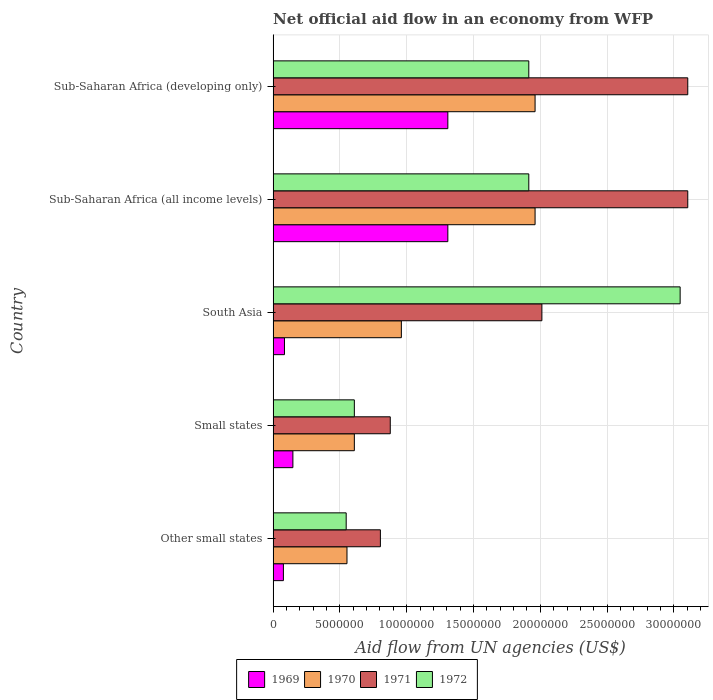How many different coloured bars are there?
Ensure brevity in your answer.  4. How many bars are there on the 5th tick from the top?
Offer a terse response. 4. What is the label of the 4th group of bars from the top?
Offer a very short reply. Small states. In how many cases, is the number of bars for a given country not equal to the number of legend labels?
Make the answer very short. 0. What is the net official aid flow in 1969 in South Asia?
Keep it short and to the point. 8.50e+05. Across all countries, what is the maximum net official aid flow in 1971?
Make the answer very short. 3.10e+07. Across all countries, what is the minimum net official aid flow in 1972?
Provide a short and direct response. 5.47e+06. In which country was the net official aid flow in 1972 minimum?
Your answer should be very brief. Other small states. What is the total net official aid flow in 1969 in the graph?
Keep it short and to the point. 2.93e+07. What is the difference between the net official aid flow in 1972 in Other small states and that in South Asia?
Provide a succinct answer. -2.50e+07. What is the difference between the net official aid flow in 1969 in Sub-Saharan Africa (all income levels) and the net official aid flow in 1972 in South Asia?
Your answer should be very brief. -1.74e+07. What is the average net official aid flow in 1970 per country?
Keep it short and to the point. 1.21e+07. What is the difference between the net official aid flow in 1969 and net official aid flow in 1972 in South Asia?
Provide a short and direct response. -2.96e+07. What is the ratio of the net official aid flow in 1971 in Other small states to that in South Asia?
Provide a short and direct response. 0.4. Is the difference between the net official aid flow in 1969 in Small states and Sub-Saharan Africa (developing only) greater than the difference between the net official aid flow in 1972 in Small states and Sub-Saharan Africa (developing only)?
Provide a succinct answer. Yes. What is the difference between the highest and the lowest net official aid flow in 1971?
Ensure brevity in your answer.  2.30e+07. In how many countries, is the net official aid flow in 1969 greater than the average net official aid flow in 1969 taken over all countries?
Provide a short and direct response. 2. What does the 3rd bar from the bottom in Small states represents?
Provide a succinct answer. 1971. Is it the case that in every country, the sum of the net official aid flow in 1969 and net official aid flow in 1971 is greater than the net official aid flow in 1970?
Your response must be concise. Yes. How many countries are there in the graph?
Your answer should be compact. 5. How are the legend labels stacked?
Offer a terse response. Horizontal. What is the title of the graph?
Ensure brevity in your answer.  Net official aid flow in an economy from WFP. What is the label or title of the X-axis?
Provide a succinct answer. Aid flow from UN agencies (US$). What is the Aid flow from UN agencies (US$) in 1969 in Other small states?
Give a very brief answer. 7.70e+05. What is the Aid flow from UN agencies (US$) in 1970 in Other small states?
Keep it short and to the point. 5.53e+06. What is the Aid flow from UN agencies (US$) in 1971 in Other small states?
Give a very brief answer. 8.03e+06. What is the Aid flow from UN agencies (US$) in 1972 in Other small states?
Provide a succinct answer. 5.47e+06. What is the Aid flow from UN agencies (US$) of 1969 in Small states?
Your answer should be very brief. 1.48e+06. What is the Aid flow from UN agencies (US$) in 1970 in Small states?
Give a very brief answer. 6.08e+06. What is the Aid flow from UN agencies (US$) of 1971 in Small states?
Offer a terse response. 8.77e+06. What is the Aid flow from UN agencies (US$) in 1972 in Small states?
Offer a very short reply. 6.08e+06. What is the Aid flow from UN agencies (US$) of 1969 in South Asia?
Your answer should be compact. 8.50e+05. What is the Aid flow from UN agencies (US$) in 1970 in South Asia?
Your answer should be very brief. 9.60e+06. What is the Aid flow from UN agencies (US$) in 1971 in South Asia?
Offer a very short reply. 2.01e+07. What is the Aid flow from UN agencies (US$) of 1972 in South Asia?
Offer a terse response. 3.05e+07. What is the Aid flow from UN agencies (US$) of 1969 in Sub-Saharan Africa (all income levels)?
Keep it short and to the point. 1.31e+07. What is the Aid flow from UN agencies (US$) in 1970 in Sub-Saharan Africa (all income levels)?
Give a very brief answer. 1.96e+07. What is the Aid flow from UN agencies (US$) of 1971 in Sub-Saharan Africa (all income levels)?
Provide a succinct answer. 3.10e+07. What is the Aid flow from UN agencies (US$) of 1972 in Sub-Saharan Africa (all income levels)?
Offer a terse response. 1.91e+07. What is the Aid flow from UN agencies (US$) in 1969 in Sub-Saharan Africa (developing only)?
Your answer should be very brief. 1.31e+07. What is the Aid flow from UN agencies (US$) of 1970 in Sub-Saharan Africa (developing only)?
Ensure brevity in your answer.  1.96e+07. What is the Aid flow from UN agencies (US$) in 1971 in Sub-Saharan Africa (developing only)?
Keep it short and to the point. 3.10e+07. What is the Aid flow from UN agencies (US$) in 1972 in Sub-Saharan Africa (developing only)?
Offer a very short reply. 1.91e+07. Across all countries, what is the maximum Aid flow from UN agencies (US$) in 1969?
Provide a succinct answer. 1.31e+07. Across all countries, what is the maximum Aid flow from UN agencies (US$) of 1970?
Your response must be concise. 1.96e+07. Across all countries, what is the maximum Aid flow from UN agencies (US$) of 1971?
Keep it short and to the point. 3.10e+07. Across all countries, what is the maximum Aid flow from UN agencies (US$) of 1972?
Ensure brevity in your answer.  3.05e+07. Across all countries, what is the minimum Aid flow from UN agencies (US$) of 1969?
Make the answer very short. 7.70e+05. Across all countries, what is the minimum Aid flow from UN agencies (US$) in 1970?
Your answer should be compact. 5.53e+06. Across all countries, what is the minimum Aid flow from UN agencies (US$) in 1971?
Provide a short and direct response. 8.03e+06. Across all countries, what is the minimum Aid flow from UN agencies (US$) in 1972?
Offer a very short reply. 5.47e+06. What is the total Aid flow from UN agencies (US$) of 1969 in the graph?
Give a very brief answer. 2.93e+07. What is the total Aid flow from UN agencies (US$) of 1970 in the graph?
Keep it short and to the point. 6.04e+07. What is the total Aid flow from UN agencies (US$) of 1971 in the graph?
Offer a terse response. 9.90e+07. What is the total Aid flow from UN agencies (US$) of 1972 in the graph?
Your response must be concise. 8.03e+07. What is the difference between the Aid flow from UN agencies (US$) of 1969 in Other small states and that in Small states?
Your answer should be compact. -7.10e+05. What is the difference between the Aid flow from UN agencies (US$) in 1970 in Other small states and that in Small states?
Give a very brief answer. -5.50e+05. What is the difference between the Aid flow from UN agencies (US$) of 1971 in Other small states and that in Small states?
Ensure brevity in your answer.  -7.40e+05. What is the difference between the Aid flow from UN agencies (US$) of 1972 in Other small states and that in Small states?
Your answer should be compact. -6.10e+05. What is the difference between the Aid flow from UN agencies (US$) of 1969 in Other small states and that in South Asia?
Make the answer very short. -8.00e+04. What is the difference between the Aid flow from UN agencies (US$) in 1970 in Other small states and that in South Asia?
Your answer should be very brief. -4.07e+06. What is the difference between the Aid flow from UN agencies (US$) of 1971 in Other small states and that in South Asia?
Provide a short and direct response. -1.21e+07. What is the difference between the Aid flow from UN agencies (US$) of 1972 in Other small states and that in South Asia?
Give a very brief answer. -2.50e+07. What is the difference between the Aid flow from UN agencies (US$) of 1969 in Other small states and that in Sub-Saharan Africa (all income levels)?
Ensure brevity in your answer.  -1.23e+07. What is the difference between the Aid flow from UN agencies (US$) of 1970 in Other small states and that in Sub-Saharan Africa (all income levels)?
Offer a terse response. -1.41e+07. What is the difference between the Aid flow from UN agencies (US$) in 1971 in Other small states and that in Sub-Saharan Africa (all income levels)?
Ensure brevity in your answer.  -2.30e+07. What is the difference between the Aid flow from UN agencies (US$) of 1972 in Other small states and that in Sub-Saharan Africa (all income levels)?
Provide a succinct answer. -1.37e+07. What is the difference between the Aid flow from UN agencies (US$) of 1969 in Other small states and that in Sub-Saharan Africa (developing only)?
Keep it short and to the point. -1.23e+07. What is the difference between the Aid flow from UN agencies (US$) in 1970 in Other small states and that in Sub-Saharan Africa (developing only)?
Provide a short and direct response. -1.41e+07. What is the difference between the Aid flow from UN agencies (US$) in 1971 in Other small states and that in Sub-Saharan Africa (developing only)?
Your answer should be compact. -2.30e+07. What is the difference between the Aid flow from UN agencies (US$) in 1972 in Other small states and that in Sub-Saharan Africa (developing only)?
Keep it short and to the point. -1.37e+07. What is the difference between the Aid flow from UN agencies (US$) of 1969 in Small states and that in South Asia?
Your answer should be compact. 6.30e+05. What is the difference between the Aid flow from UN agencies (US$) in 1970 in Small states and that in South Asia?
Your response must be concise. -3.52e+06. What is the difference between the Aid flow from UN agencies (US$) of 1971 in Small states and that in South Asia?
Give a very brief answer. -1.14e+07. What is the difference between the Aid flow from UN agencies (US$) in 1972 in Small states and that in South Asia?
Provide a succinct answer. -2.44e+07. What is the difference between the Aid flow from UN agencies (US$) in 1969 in Small states and that in Sub-Saharan Africa (all income levels)?
Offer a very short reply. -1.16e+07. What is the difference between the Aid flow from UN agencies (US$) in 1970 in Small states and that in Sub-Saharan Africa (all income levels)?
Your response must be concise. -1.35e+07. What is the difference between the Aid flow from UN agencies (US$) in 1971 in Small states and that in Sub-Saharan Africa (all income levels)?
Your response must be concise. -2.23e+07. What is the difference between the Aid flow from UN agencies (US$) of 1972 in Small states and that in Sub-Saharan Africa (all income levels)?
Keep it short and to the point. -1.31e+07. What is the difference between the Aid flow from UN agencies (US$) of 1969 in Small states and that in Sub-Saharan Africa (developing only)?
Offer a terse response. -1.16e+07. What is the difference between the Aid flow from UN agencies (US$) in 1970 in Small states and that in Sub-Saharan Africa (developing only)?
Provide a short and direct response. -1.35e+07. What is the difference between the Aid flow from UN agencies (US$) of 1971 in Small states and that in Sub-Saharan Africa (developing only)?
Provide a short and direct response. -2.23e+07. What is the difference between the Aid flow from UN agencies (US$) in 1972 in Small states and that in Sub-Saharan Africa (developing only)?
Offer a terse response. -1.31e+07. What is the difference between the Aid flow from UN agencies (US$) of 1969 in South Asia and that in Sub-Saharan Africa (all income levels)?
Give a very brief answer. -1.22e+07. What is the difference between the Aid flow from UN agencies (US$) of 1970 in South Asia and that in Sub-Saharan Africa (all income levels)?
Give a very brief answer. -1.00e+07. What is the difference between the Aid flow from UN agencies (US$) in 1971 in South Asia and that in Sub-Saharan Africa (all income levels)?
Offer a terse response. -1.09e+07. What is the difference between the Aid flow from UN agencies (US$) in 1972 in South Asia and that in Sub-Saharan Africa (all income levels)?
Keep it short and to the point. 1.13e+07. What is the difference between the Aid flow from UN agencies (US$) in 1969 in South Asia and that in Sub-Saharan Africa (developing only)?
Provide a succinct answer. -1.22e+07. What is the difference between the Aid flow from UN agencies (US$) in 1970 in South Asia and that in Sub-Saharan Africa (developing only)?
Give a very brief answer. -1.00e+07. What is the difference between the Aid flow from UN agencies (US$) in 1971 in South Asia and that in Sub-Saharan Africa (developing only)?
Your answer should be very brief. -1.09e+07. What is the difference between the Aid flow from UN agencies (US$) of 1972 in South Asia and that in Sub-Saharan Africa (developing only)?
Your answer should be compact. 1.13e+07. What is the difference between the Aid flow from UN agencies (US$) of 1972 in Sub-Saharan Africa (all income levels) and that in Sub-Saharan Africa (developing only)?
Give a very brief answer. 0. What is the difference between the Aid flow from UN agencies (US$) of 1969 in Other small states and the Aid flow from UN agencies (US$) of 1970 in Small states?
Your response must be concise. -5.31e+06. What is the difference between the Aid flow from UN agencies (US$) in 1969 in Other small states and the Aid flow from UN agencies (US$) in 1971 in Small states?
Your response must be concise. -8.00e+06. What is the difference between the Aid flow from UN agencies (US$) in 1969 in Other small states and the Aid flow from UN agencies (US$) in 1972 in Small states?
Give a very brief answer. -5.31e+06. What is the difference between the Aid flow from UN agencies (US$) of 1970 in Other small states and the Aid flow from UN agencies (US$) of 1971 in Small states?
Provide a succinct answer. -3.24e+06. What is the difference between the Aid flow from UN agencies (US$) of 1970 in Other small states and the Aid flow from UN agencies (US$) of 1972 in Small states?
Give a very brief answer. -5.50e+05. What is the difference between the Aid flow from UN agencies (US$) of 1971 in Other small states and the Aid flow from UN agencies (US$) of 1972 in Small states?
Offer a terse response. 1.95e+06. What is the difference between the Aid flow from UN agencies (US$) in 1969 in Other small states and the Aid flow from UN agencies (US$) in 1970 in South Asia?
Your response must be concise. -8.83e+06. What is the difference between the Aid flow from UN agencies (US$) in 1969 in Other small states and the Aid flow from UN agencies (US$) in 1971 in South Asia?
Ensure brevity in your answer.  -1.94e+07. What is the difference between the Aid flow from UN agencies (US$) in 1969 in Other small states and the Aid flow from UN agencies (US$) in 1972 in South Asia?
Your answer should be compact. -2.97e+07. What is the difference between the Aid flow from UN agencies (US$) of 1970 in Other small states and the Aid flow from UN agencies (US$) of 1971 in South Asia?
Provide a succinct answer. -1.46e+07. What is the difference between the Aid flow from UN agencies (US$) of 1970 in Other small states and the Aid flow from UN agencies (US$) of 1972 in South Asia?
Keep it short and to the point. -2.49e+07. What is the difference between the Aid flow from UN agencies (US$) of 1971 in Other small states and the Aid flow from UN agencies (US$) of 1972 in South Asia?
Provide a short and direct response. -2.24e+07. What is the difference between the Aid flow from UN agencies (US$) in 1969 in Other small states and the Aid flow from UN agencies (US$) in 1970 in Sub-Saharan Africa (all income levels)?
Your answer should be very brief. -1.88e+07. What is the difference between the Aid flow from UN agencies (US$) of 1969 in Other small states and the Aid flow from UN agencies (US$) of 1971 in Sub-Saharan Africa (all income levels)?
Ensure brevity in your answer.  -3.03e+07. What is the difference between the Aid flow from UN agencies (US$) of 1969 in Other small states and the Aid flow from UN agencies (US$) of 1972 in Sub-Saharan Africa (all income levels)?
Your answer should be very brief. -1.84e+07. What is the difference between the Aid flow from UN agencies (US$) of 1970 in Other small states and the Aid flow from UN agencies (US$) of 1971 in Sub-Saharan Africa (all income levels)?
Provide a short and direct response. -2.55e+07. What is the difference between the Aid flow from UN agencies (US$) in 1970 in Other small states and the Aid flow from UN agencies (US$) in 1972 in Sub-Saharan Africa (all income levels)?
Make the answer very short. -1.36e+07. What is the difference between the Aid flow from UN agencies (US$) of 1971 in Other small states and the Aid flow from UN agencies (US$) of 1972 in Sub-Saharan Africa (all income levels)?
Make the answer very short. -1.11e+07. What is the difference between the Aid flow from UN agencies (US$) in 1969 in Other small states and the Aid flow from UN agencies (US$) in 1970 in Sub-Saharan Africa (developing only)?
Keep it short and to the point. -1.88e+07. What is the difference between the Aid flow from UN agencies (US$) in 1969 in Other small states and the Aid flow from UN agencies (US$) in 1971 in Sub-Saharan Africa (developing only)?
Ensure brevity in your answer.  -3.03e+07. What is the difference between the Aid flow from UN agencies (US$) of 1969 in Other small states and the Aid flow from UN agencies (US$) of 1972 in Sub-Saharan Africa (developing only)?
Ensure brevity in your answer.  -1.84e+07. What is the difference between the Aid flow from UN agencies (US$) of 1970 in Other small states and the Aid flow from UN agencies (US$) of 1971 in Sub-Saharan Africa (developing only)?
Offer a very short reply. -2.55e+07. What is the difference between the Aid flow from UN agencies (US$) of 1970 in Other small states and the Aid flow from UN agencies (US$) of 1972 in Sub-Saharan Africa (developing only)?
Offer a very short reply. -1.36e+07. What is the difference between the Aid flow from UN agencies (US$) in 1971 in Other small states and the Aid flow from UN agencies (US$) in 1972 in Sub-Saharan Africa (developing only)?
Your answer should be very brief. -1.11e+07. What is the difference between the Aid flow from UN agencies (US$) in 1969 in Small states and the Aid flow from UN agencies (US$) in 1970 in South Asia?
Provide a short and direct response. -8.12e+06. What is the difference between the Aid flow from UN agencies (US$) of 1969 in Small states and the Aid flow from UN agencies (US$) of 1971 in South Asia?
Ensure brevity in your answer.  -1.86e+07. What is the difference between the Aid flow from UN agencies (US$) in 1969 in Small states and the Aid flow from UN agencies (US$) in 1972 in South Asia?
Offer a very short reply. -2.90e+07. What is the difference between the Aid flow from UN agencies (US$) in 1970 in Small states and the Aid flow from UN agencies (US$) in 1971 in South Asia?
Give a very brief answer. -1.40e+07. What is the difference between the Aid flow from UN agencies (US$) in 1970 in Small states and the Aid flow from UN agencies (US$) in 1972 in South Asia?
Ensure brevity in your answer.  -2.44e+07. What is the difference between the Aid flow from UN agencies (US$) of 1971 in Small states and the Aid flow from UN agencies (US$) of 1972 in South Asia?
Keep it short and to the point. -2.17e+07. What is the difference between the Aid flow from UN agencies (US$) in 1969 in Small states and the Aid flow from UN agencies (US$) in 1970 in Sub-Saharan Africa (all income levels)?
Ensure brevity in your answer.  -1.81e+07. What is the difference between the Aid flow from UN agencies (US$) in 1969 in Small states and the Aid flow from UN agencies (US$) in 1971 in Sub-Saharan Africa (all income levels)?
Your answer should be very brief. -2.96e+07. What is the difference between the Aid flow from UN agencies (US$) in 1969 in Small states and the Aid flow from UN agencies (US$) in 1972 in Sub-Saharan Africa (all income levels)?
Ensure brevity in your answer.  -1.77e+07. What is the difference between the Aid flow from UN agencies (US$) in 1970 in Small states and the Aid flow from UN agencies (US$) in 1971 in Sub-Saharan Africa (all income levels)?
Make the answer very short. -2.50e+07. What is the difference between the Aid flow from UN agencies (US$) of 1970 in Small states and the Aid flow from UN agencies (US$) of 1972 in Sub-Saharan Africa (all income levels)?
Ensure brevity in your answer.  -1.31e+07. What is the difference between the Aid flow from UN agencies (US$) of 1971 in Small states and the Aid flow from UN agencies (US$) of 1972 in Sub-Saharan Africa (all income levels)?
Keep it short and to the point. -1.04e+07. What is the difference between the Aid flow from UN agencies (US$) of 1969 in Small states and the Aid flow from UN agencies (US$) of 1970 in Sub-Saharan Africa (developing only)?
Make the answer very short. -1.81e+07. What is the difference between the Aid flow from UN agencies (US$) in 1969 in Small states and the Aid flow from UN agencies (US$) in 1971 in Sub-Saharan Africa (developing only)?
Ensure brevity in your answer.  -2.96e+07. What is the difference between the Aid flow from UN agencies (US$) in 1969 in Small states and the Aid flow from UN agencies (US$) in 1972 in Sub-Saharan Africa (developing only)?
Give a very brief answer. -1.77e+07. What is the difference between the Aid flow from UN agencies (US$) of 1970 in Small states and the Aid flow from UN agencies (US$) of 1971 in Sub-Saharan Africa (developing only)?
Keep it short and to the point. -2.50e+07. What is the difference between the Aid flow from UN agencies (US$) in 1970 in Small states and the Aid flow from UN agencies (US$) in 1972 in Sub-Saharan Africa (developing only)?
Your answer should be compact. -1.31e+07. What is the difference between the Aid flow from UN agencies (US$) in 1971 in Small states and the Aid flow from UN agencies (US$) in 1972 in Sub-Saharan Africa (developing only)?
Make the answer very short. -1.04e+07. What is the difference between the Aid flow from UN agencies (US$) of 1969 in South Asia and the Aid flow from UN agencies (US$) of 1970 in Sub-Saharan Africa (all income levels)?
Make the answer very short. -1.88e+07. What is the difference between the Aid flow from UN agencies (US$) in 1969 in South Asia and the Aid flow from UN agencies (US$) in 1971 in Sub-Saharan Africa (all income levels)?
Provide a succinct answer. -3.02e+07. What is the difference between the Aid flow from UN agencies (US$) in 1969 in South Asia and the Aid flow from UN agencies (US$) in 1972 in Sub-Saharan Africa (all income levels)?
Offer a very short reply. -1.83e+07. What is the difference between the Aid flow from UN agencies (US$) in 1970 in South Asia and the Aid flow from UN agencies (US$) in 1971 in Sub-Saharan Africa (all income levels)?
Provide a short and direct response. -2.14e+07. What is the difference between the Aid flow from UN agencies (US$) in 1970 in South Asia and the Aid flow from UN agencies (US$) in 1972 in Sub-Saharan Africa (all income levels)?
Offer a terse response. -9.54e+06. What is the difference between the Aid flow from UN agencies (US$) of 1971 in South Asia and the Aid flow from UN agencies (US$) of 1972 in Sub-Saharan Africa (all income levels)?
Provide a short and direct response. 9.80e+05. What is the difference between the Aid flow from UN agencies (US$) of 1969 in South Asia and the Aid flow from UN agencies (US$) of 1970 in Sub-Saharan Africa (developing only)?
Offer a very short reply. -1.88e+07. What is the difference between the Aid flow from UN agencies (US$) in 1969 in South Asia and the Aid flow from UN agencies (US$) in 1971 in Sub-Saharan Africa (developing only)?
Keep it short and to the point. -3.02e+07. What is the difference between the Aid flow from UN agencies (US$) of 1969 in South Asia and the Aid flow from UN agencies (US$) of 1972 in Sub-Saharan Africa (developing only)?
Ensure brevity in your answer.  -1.83e+07. What is the difference between the Aid flow from UN agencies (US$) in 1970 in South Asia and the Aid flow from UN agencies (US$) in 1971 in Sub-Saharan Africa (developing only)?
Offer a very short reply. -2.14e+07. What is the difference between the Aid flow from UN agencies (US$) of 1970 in South Asia and the Aid flow from UN agencies (US$) of 1972 in Sub-Saharan Africa (developing only)?
Your answer should be very brief. -9.54e+06. What is the difference between the Aid flow from UN agencies (US$) in 1971 in South Asia and the Aid flow from UN agencies (US$) in 1972 in Sub-Saharan Africa (developing only)?
Keep it short and to the point. 9.80e+05. What is the difference between the Aid flow from UN agencies (US$) in 1969 in Sub-Saharan Africa (all income levels) and the Aid flow from UN agencies (US$) in 1970 in Sub-Saharan Africa (developing only)?
Your response must be concise. -6.53e+06. What is the difference between the Aid flow from UN agencies (US$) in 1969 in Sub-Saharan Africa (all income levels) and the Aid flow from UN agencies (US$) in 1971 in Sub-Saharan Africa (developing only)?
Your response must be concise. -1.80e+07. What is the difference between the Aid flow from UN agencies (US$) in 1969 in Sub-Saharan Africa (all income levels) and the Aid flow from UN agencies (US$) in 1972 in Sub-Saharan Africa (developing only)?
Your answer should be very brief. -6.06e+06. What is the difference between the Aid flow from UN agencies (US$) of 1970 in Sub-Saharan Africa (all income levels) and the Aid flow from UN agencies (US$) of 1971 in Sub-Saharan Africa (developing only)?
Provide a succinct answer. -1.14e+07. What is the difference between the Aid flow from UN agencies (US$) of 1971 in Sub-Saharan Africa (all income levels) and the Aid flow from UN agencies (US$) of 1972 in Sub-Saharan Africa (developing only)?
Your answer should be very brief. 1.19e+07. What is the average Aid flow from UN agencies (US$) of 1969 per country?
Your response must be concise. 5.85e+06. What is the average Aid flow from UN agencies (US$) of 1970 per country?
Give a very brief answer. 1.21e+07. What is the average Aid flow from UN agencies (US$) in 1971 per country?
Ensure brevity in your answer.  1.98e+07. What is the average Aid flow from UN agencies (US$) of 1972 per country?
Your response must be concise. 1.61e+07. What is the difference between the Aid flow from UN agencies (US$) of 1969 and Aid flow from UN agencies (US$) of 1970 in Other small states?
Offer a very short reply. -4.76e+06. What is the difference between the Aid flow from UN agencies (US$) of 1969 and Aid flow from UN agencies (US$) of 1971 in Other small states?
Ensure brevity in your answer.  -7.26e+06. What is the difference between the Aid flow from UN agencies (US$) in 1969 and Aid flow from UN agencies (US$) in 1972 in Other small states?
Your response must be concise. -4.70e+06. What is the difference between the Aid flow from UN agencies (US$) in 1970 and Aid flow from UN agencies (US$) in 1971 in Other small states?
Provide a short and direct response. -2.50e+06. What is the difference between the Aid flow from UN agencies (US$) in 1971 and Aid flow from UN agencies (US$) in 1972 in Other small states?
Your answer should be compact. 2.56e+06. What is the difference between the Aid flow from UN agencies (US$) of 1969 and Aid flow from UN agencies (US$) of 1970 in Small states?
Your answer should be very brief. -4.60e+06. What is the difference between the Aid flow from UN agencies (US$) in 1969 and Aid flow from UN agencies (US$) in 1971 in Small states?
Your answer should be very brief. -7.29e+06. What is the difference between the Aid flow from UN agencies (US$) of 1969 and Aid flow from UN agencies (US$) of 1972 in Small states?
Make the answer very short. -4.60e+06. What is the difference between the Aid flow from UN agencies (US$) of 1970 and Aid flow from UN agencies (US$) of 1971 in Small states?
Your response must be concise. -2.69e+06. What is the difference between the Aid flow from UN agencies (US$) of 1971 and Aid flow from UN agencies (US$) of 1972 in Small states?
Your response must be concise. 2.69e+06. What is the difference between the Aid flow from UN agencies (US$) of 1969 and Aid flow from UN agencies (US$) of 1970 in South Asia?
Make the answer very short. -8.75e+06. What is the difference between the Aid flow from UN agencies (US$) in 1969 and Aid flow from UN agencies (US$) in 1971 in South Asia?
Offer a very short reply. -1.93e+07. What is the difference between the Aid flow from UN agencies (US$) of 1969 and Aid flow from UN agencies (US$) of 1972 in South Asia?
Offer a terse response. -2.96e+07. What is the difference between the Aid flow from UN agencies (US$) in 1970 and Aid flow from UN agencies (US$) in 1971 in South Asia?
Your answer should be very brief. -1.05e+07. What is the difference between the Aid flow from UN agencies (US$) in 1970 and Aid flow from UN agencies (US$) in 1972 in South Asia?
Offer a very short reply. -2.09e+07. What is the difference between the Aid flow from UN agencies (US$) in 1971 and Aid flow from UN agencies (US$) in 1972 in South Asia?
Make the answer very short. -1.04e+07. What is the difference between the Aid flow from UN agencies (US$) of 1969 and Aid flow from UN agencies (US$) of 1970 in Sub-Saharan Africa (all income levels)?
Keep it short and to the point. -6.53e+06. What is the difference between the Aid flow from UN agencies (US$) in 1969 and Aid flow from UN agencies (US$) in 1971 in Sub-Saharan Africa (all income levels)?
Your answer should be compact. -1.80e+07. What is the difference between the Aid flow from UN agencies (US$) in 1969 and Aid flow from UN agencies (US$) in 1972 in Sub-Saharan Africa (all income levels)?
Your answer should be compact. -6.06e+06. What is the difference between the Aid flow from UN agencies (US$) of 1970 and Aid flow from UN agencies (US$) of 1971 in Sub-Saharan Africa (all income levels)?
Your answer should be very brief. -1.14e+07. What is the difference between the Aid flow from UN agencies (US$) in 1971 and Aid flow from UN agencies (US$) in 1972 in Sub-Saharan Africa (all income levels)?
Give a very brief answer. 1.19e+07. What is the difference between the Aid flow from UN agencies (US$) of 1969 and Aid flow from UN agencies (US$) of 1970 in Sub-Saharan Africa (developing only)?
Offer a terse response. -6.53e+06. What is the difference between the Aid flow from UN agencies (US$) in 1969 and Aid flow from UN agencies (US$) in 1971 in Sub-Saharan Africa (developing only)?
Your answer should be compact. -1.80e+07. What is the difference between the Aid flow from UN agencies (US$) in 1969 and Aid flow from UN agencies (US$) in 1972 in Sub-Saharan Africa (developing only)?
Ensure brevity in your answer.  -6.06e+06. What is the difference between the Aid flow from UN agencies (US$) in 1970 and Aid flow from UN agencies (US$) in 1971 in Sub-Saharan Africa (developing only)?
Your answer should be compact. -1.14e+07. What is the difference between the Aid flow from UN agencies (US$) of 1971 and Aid flow from UN agencies (US$) of 1972 in Sub-Saharan Africa (developing only)?
Offer a terse response. 1.19e+07. What is the ratio of the Aid flow from UN agencies (US$) of 1969 in Other small states to that in Small states?
Keep it short and to the point. 0.52. What is the ratio of the Aid flow from UN agencies (US$) in 1970 in Other small states to that in Small states?
Offer a terse response. 0.91. What is the ratio of the Aid flow from UN agencies (US$) in 1971 in Other small states to that in Small states?
Provide a short and direct response. 0.92. What is the ratio of the Aid flow from UN agencies (US$) of 1972 in Other small states to that in Small states?
Make the answer very short. 0.9. What is the ratio of the Aid flow from UN agencies (US$) in 1969 in Other small states to that in South Asia?
Make the answer very short. 0.91. What is the ratio of the Aid flow from UN agencies (US$) in 1970 in Other small states to that in South Asia?
Provide a succinct answer. 0.58. What is the ratio of the Aid flow from UN agencies (US$) of 1971 in Other small states to that in South Asia?
Offer a terse response. 0.4. What is the ratio of the Aid flow from UN agencies (US$) in 1972 in Other small states to that in South Asia?
Offer a terse response. 0.18. What is the ratio of the Aid flow from UN agencies (US$) in 1969 in Other small states to that in Sub-Saharan Africa (all income levels)?
Your answer should be compact. 0.06. What is the ratio of the Aid flow from UN agencies (US$) in 1970 in Other small states to that in Sub-Saharan Africa (all income levels)?
Provide a short and direct response. 0.28. What is the ratio of the Aid flow from UN agencies (US$) in 1971 in Other small states to that in Sub-Saharan Africa (all income levels)?
Ensure brevity in your answer.  0.26. What is the ratio of the Aid flow from UN agencies (US$) of 1972 in Other small states to that in Sub-Saharan Africa (all income levels)?
Provide a short and direct response. 0.29. What is the ratio of the Aid flow from UN agencies (US$) in 1969 in Other small states to that in Sub-Saharan Africa (developing only)?
Your response must be concise. 0.06. What is the ratio of the Aid flow from UN agencies (US$) in 1970 in Other small states to that in Sub-Saharan Africa (developing only)?
Your answer should be compact. 0.28. What is the ratio of the Aid flow from UN agencies (US$) of 1971 in Other small states to that in Sub-Saharan Africa (developing only)?
Offer a very short reply. 0.26. What is the ratio of the Aid flow from UN agencies (US$) in 1972 in Other small states to that in Sub-Saharan Africa (developing only)?
Offer a very short reply. 0.29. What is the ratio of the Aid flow from UN agencies (US$) of 1969 in Small states to that in South Asia?
Your answer should be compact. 1.74. What is the ratio of the Aid flow from UN agencies (US$) in 1970 in Small states to that in South Asia?
Provide a succinct answer. 0.63. What is the ratio of the Aid flow from UN agencies (US$) in 1971 in Small states to that in South Asia?
Keep it short and to the point. 0.44. What is the ratio of the Aid flow from UN agencies (US$) in 1972 in Small states to that in South Asia?
Provide a succinct answer. 0.2. What is the ratio of the Aid flow from UN agencies (US$) in 1969 in Small states to that in Sub-Saharan Africa (all income levels)?
Your response must be concise. 0.11. What is the ratio of the Aid flow from UN agencies (US$) in 1970 in Small states to that in Sub-Saharan Africa (all income levels)?
Give a very brief answer. 0.31. What is the ratio of the Aid flow from UN agencies (US$) in 1971 in Small states to that in Sub-Saharan Africa (all income levels)?
Ensure brevity in your answer.  0.28. What is the ratio of the Aid flow from UN agencies (US$) in 1972 in Small states to that in Sub-Saharan Africa (all income levels)?
Offer a very short reply. 0.32. What is the ratio of the Aid flow from UN agencies (US$) of 1969 in Small states to that in Sub-Saharan Africa (developing only)?
Your answer should be compact. 0.11. What is the ratio of the Aid flow from UN agencies (US$) of 1970 in Small states to that in Sub-Saharan Africa (developing only)?
Give a very brief answer. 0.31. What is the ratio of the Aid flow from UN agencies (US$) in 1971 in Small states to that in Sub-Saharan Africa (developing only)?
Make the answer very short. 0.28. What is the ratio of the Aid flow from UN agencies (US$) of 1972 in Small states to that in Sub-Saharan Africa (developing only)?
Offer a very short reply. 0.32. What is the ratio of the Aid flow from UN agencies (US$) of 1969 in South Asia to that in Sub-Saharan Africa (all income levels)?
Provide a short and direct response. 0.07. What is the ratio of the Aid flow from UN agencies (US$) of 1970 in South Asia to that in Sub-Saharan Africa (all income levels)?
Ensure brevity in your answer.  0.49. What is the ratio of the Aid flow from UN agencies (US$) of 1971 in South Asia to that in Sub-Saharan Africa (all income levels)?
Provide a succinct answer. 0.65. What is the ratio of the Aid flow from UN agencies (US$) in 1972 in South Asia to that in Sub-Saharan Africa (all income levels)?
Offer a very short reply. 1.59. What is the ratio of the Aid flow from UN agencies (US$) in 1969 in South Asia to that in Sub-Saharan Africa (developing only)?
Your response must be concise. 0.07. What is the ratio of the Aid flow from UN agencies (US$) of 1970 in South Asia to that in Sub-Saharan Africa (developing only)?
Offer a terse response. 0.49. What is the ratio of the Aid flow from UN agencies (US$) in 1971 in South Asia to that in Sub-Saharan Africa (developing only)?
Make the answer very short. 0.65. What is the ratio of the Aid flow from UN agencies (US$) of 1972 in South Asia to that in Sub-Saharan Africa (developing only)?
Your answer should be very brief. 1.59. What is the ratio of the Aid flow from UN agencies (US$) in 1970 in Sub-Saharan Africa (all income levels) to that in Sub-Saharan Africa (developing only)?
Your response must be concise. 1. What is the ratio of the Aid flow from UN agencies (US$) of 1971 in Sub-Saharan Africa (all income levels) to that in Sub-Saharan Africa (developing only)?
Your answer should be very brief. 1. What is the ratio of the Aid flow from UN agencies (US$) of 1972 in Sub-Saharan Africa (all income levels) to that in Sub-Saharan Africa (developing only)?
Your response must be concise. 1. What is the difference between the highest and the second highest Aid flow from UN agencies (US$) of 1971?
Make the answer very short. 0. What is the difference between the highest and the second highest Aid flow from UN agencies (US$) in 1972?
Provide a short and direct response. 1.13e+07. What is the difference between the highest and the lowest Aid flow from UN agencies (US$) of 1969?
Your answer should be very brief. 1.23e+07. What is the difference between the highest and the lowest Aid flow from UN agencies (US$) of 1970?
Offer a terse response. 1.41e+07. What is the difference between the highest and the lowest Aid flow from UN agencies (US$) in 1971?
Your response must be concise. 2.30e+07. What is the difference between the highest and the lowest Aid flow from UN agencies (US$) of 1972?
Offer a terse response. 2.50e+07. 